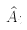Convert formula to latex. <formula><loc_0><loc_0><loc_500><loc_500>\hat { A } _ { i }</formula> 